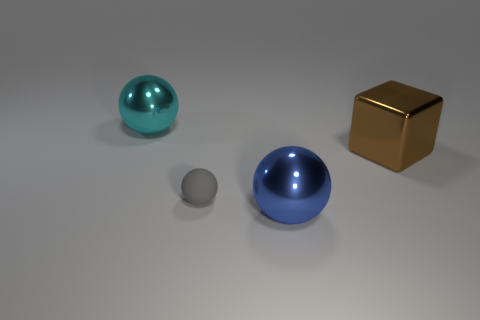Are there any other things that are the same size as the rubber object?
Keep it short and to the point. No. There is a large brown metallic cube; what number of shiny blocks are on the right side of it?
Give a very brief answer. 0. Is the material of the thing in front of the gray sphere the same as the large thing that is behind the shiny block?
Offer a terse response. Yes. What number of objects are large spheres that are left of the large blue sphere or large spheres?
Make the answer very short. 2. Is the number of cyan spheres that are in front of the block less than the number of blue things that are right of the small ball?
Your answer should be compact. Yes. How many other things are the same size as the blue metallic object?
Give a very brief answer. 2. Is the material of the large brown object the same as the big thing on the left side of the big blue object?
Keep it short and to the point. Yes. What number of objects are either objects that are in front of the big cyan object or big things to the left of the small gray rubber ball?
Ensure brevity in your answer.  4. The big block is what color?
Offer a very short reply. Brown. Are there fewer large blue shiny things behind the large brown metallic block than big green metallic spheres?
Offer a very short reply. No. 